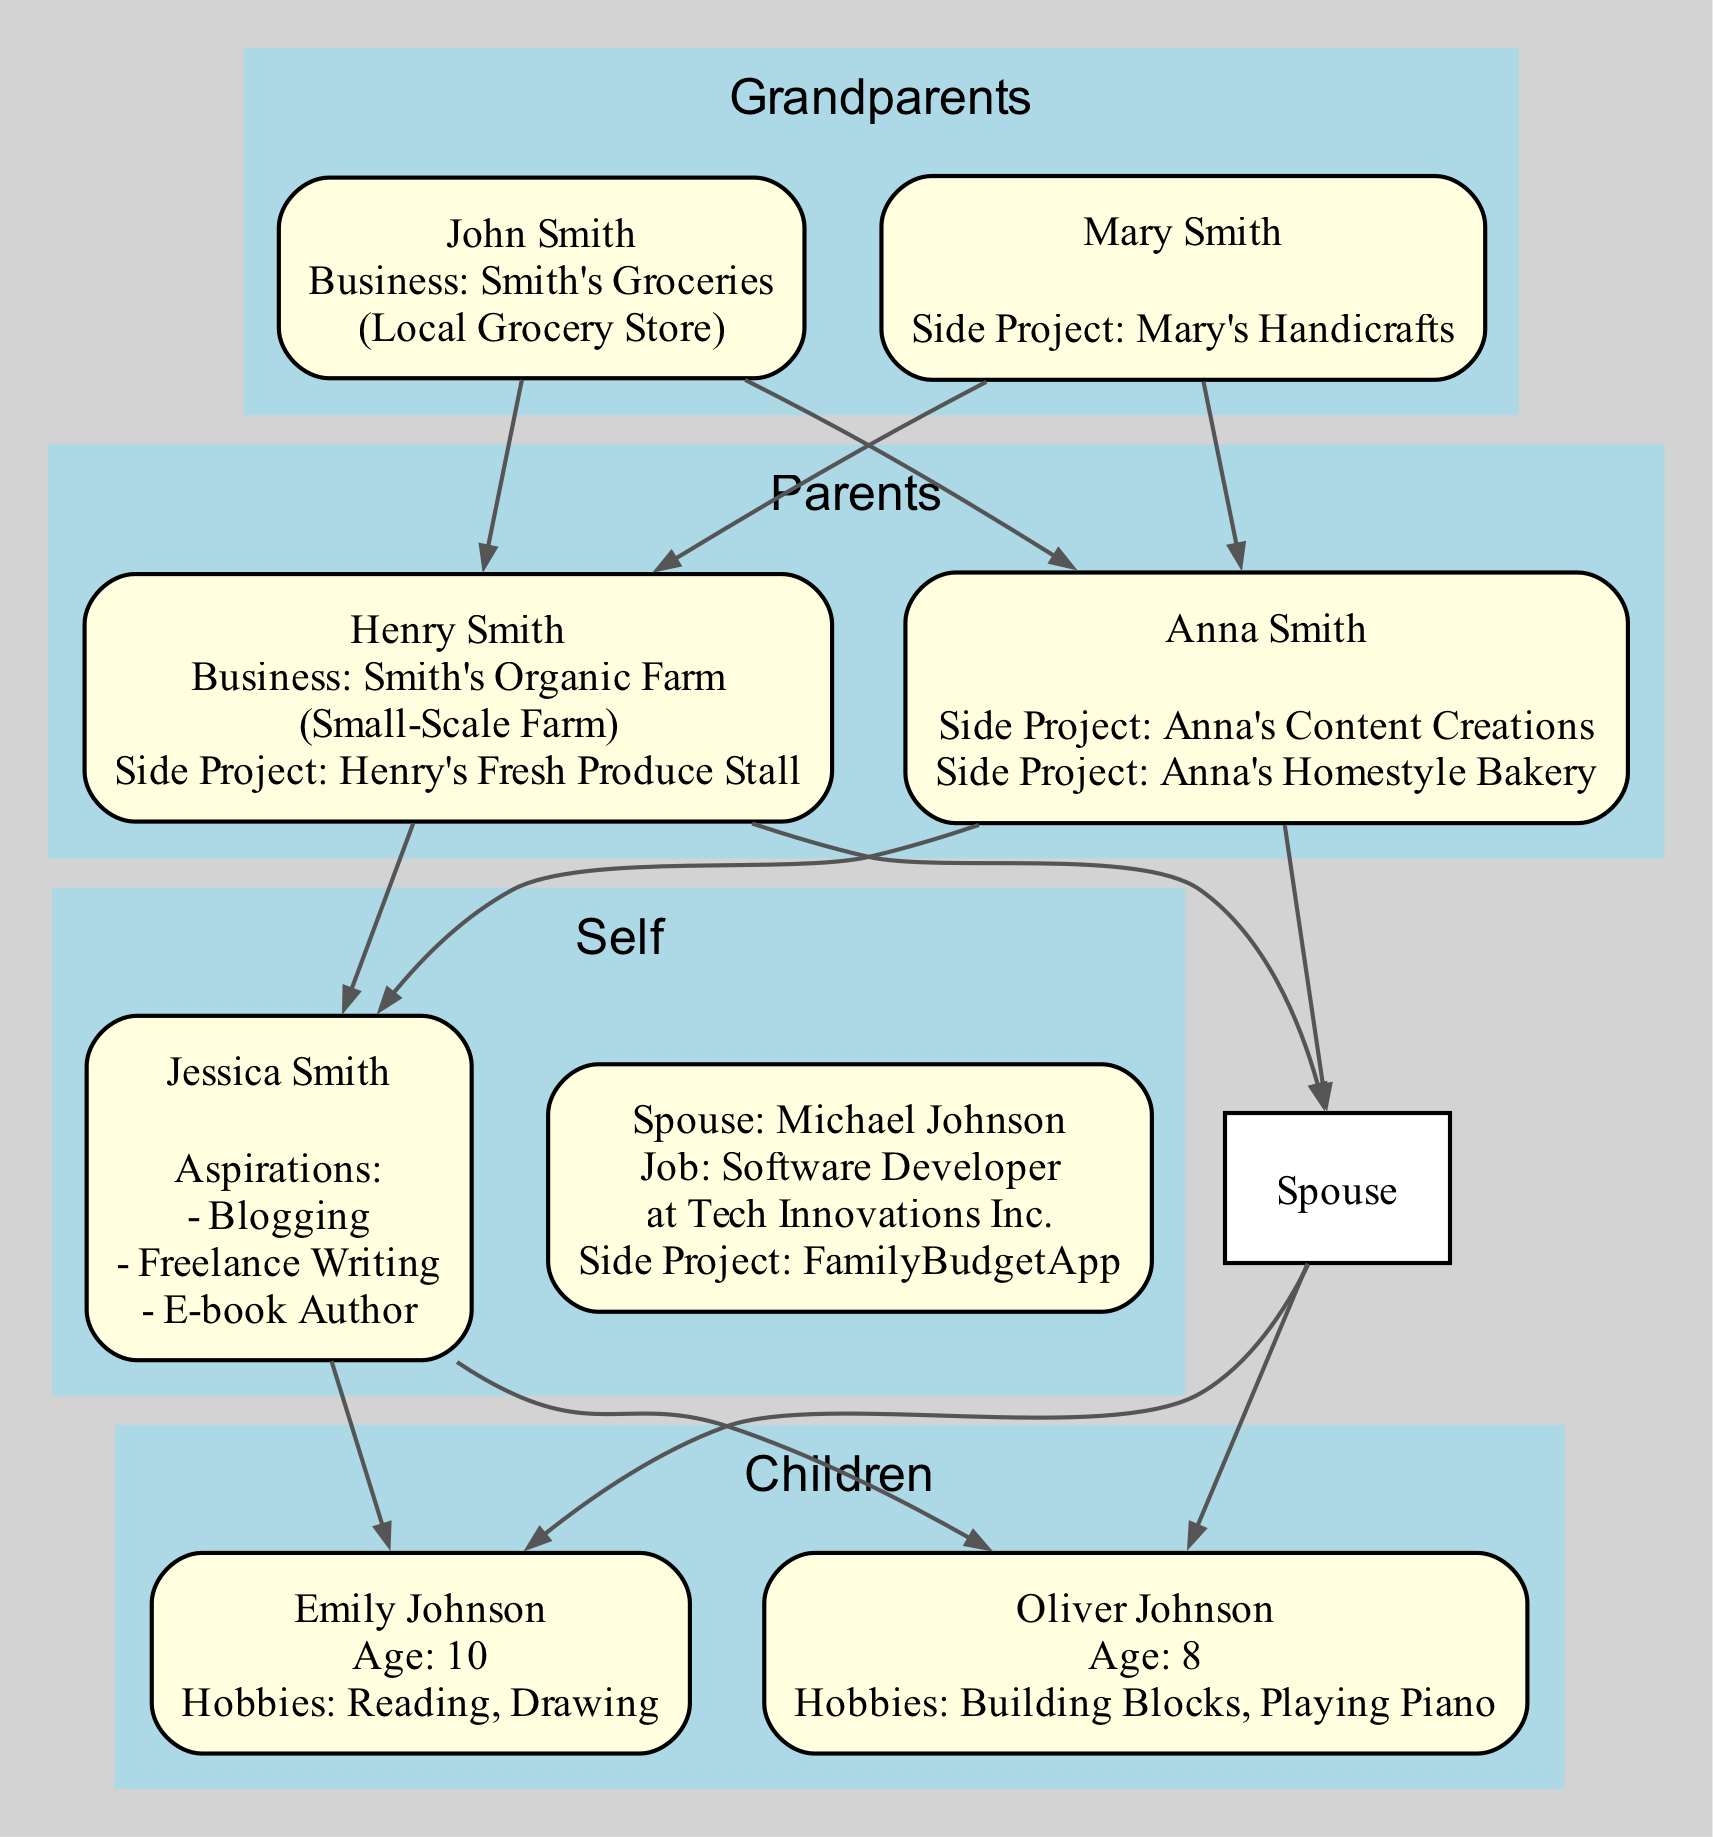What is the name of the business founded by John Smith? The diagram shows John Smith as the owner of "Smith's Groceries," which is identified as a local grocery store founded in 1950.
Answer: Smith's Groceries Who has a side project related to handmade crafts? According to the diagram, Mary Smith is noted for her side project "Mary's Handicrafts," which focuses on handmade crafts.
Answer: Mary Smith How many members are in the "Parents" generation? The diagram displays two members in the "Parents" generation: Henry Smith and Anna Smith.
Answer: 2 What type of business does Henry Smith run? The diagram indicates that Henry Smith operates "Smith's Organic Farm," which is categorized as a small-scale farm.
Answer: Small-Scale Farm What are Jessica Smith's potential niches for blogging? The diagram reveals that Jessica Smith is interested in blogging niches such as "Parenting Tips" and "DIY Craft Ideas."
Answer: Parenting Tips, DIY Craft Ideas What job does Michael Johnson currently hold? The diagram specifies that Michael Johnson is a software developer at "Tech Innovations Inc."
Answer: Software Developer Which child has an interest in becoming a musician? The diagram lists Oliver Johnson, who is identified as having potential future interests as a musician.
Answer: Oliver Johnson What year was "Smith's Organic Farm" founded? The diagram states that "Smith's Organic Farm" was founded in 1980.
Answer: 1980 Who has aspirations in freelance writing? The diagram shows that both Anna Smith and Jessica Smith have aspirations in freelance writing, with Jessica focusing on fiction writing and family stories.
Answer: Anna Smith, Jessica Smith 